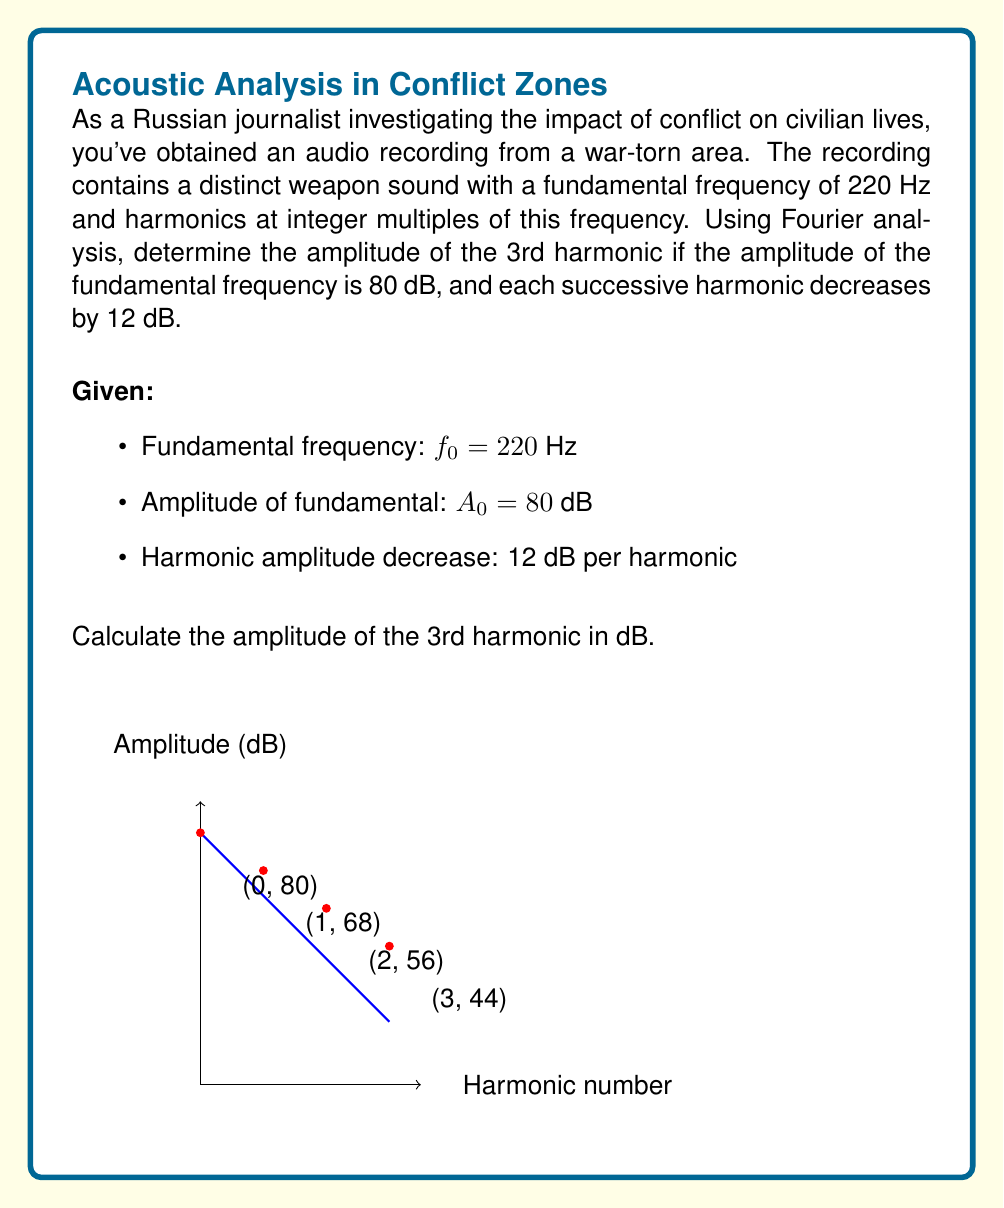What is the answer to this math problem? To solve this problem, we need to understand the relationship between harmonics and their amplitudes:

1) The fundamental frequency $f_0 = 220$ Hz has an amplitude of 80 dB.

2) Each successive harmonic decreases by 12 dB.

3) The 3rd harmonic is two steps away from the fundamental (1st harmonic).

Let's calculate step-by-step:

1) Amplitude of 1st harmonic (fundamental): $A_1 = 80$ dB

2) Amplitude of 2nd harmonic: $A_2 = A_1 - 12 = 80 - 12 = 68$ dB

3) Amplitude of 3rd harmonic: $A_3 = A_2 - 12 = 68 - 12 = 56$ dB

Alternatively, we can use a general formula:

$$A_n = A_0 - 12(n-1)$$

where $A_n$ is the amplitude of the nth harmonic, $A_0$ is the amplitude of the fundamental, and $n$ is the harmonic number.

For the 3rd harmonic:

$$A_3 = 80 - 12(3-1) = 80 - 24 = 56$$ dB

This analysis helps identify the weapon type by its unique harmonic signature, crucial for understanding the nature of conflicts and their impact on civilian areas.
Answer: 56 dB 